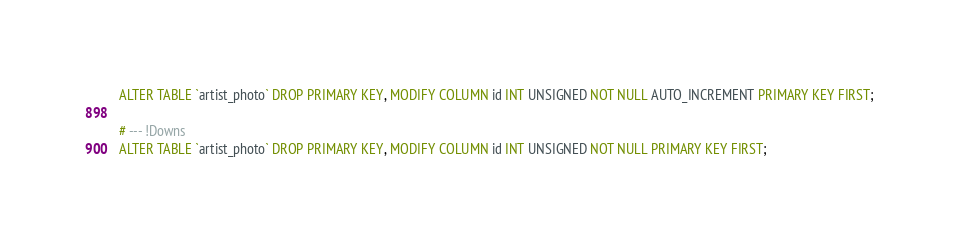<code> <loc_0><loc_0><loc_500><loc_500><_SQL_>ALTER TABLE `artist_photo` DROP PRIMARY KEY, MODIFY COLUMN id INT UNSIGNED NOT NULL AUTO_INCREMENT PRIMARY KEY FIRST;

# --- !Downs
ALTER TABLE `artist_photo` DROP PRIMARY KEY, MODIFY COLUMN id INT UNSIGNED NOT NULL PRIMARY KEY FIRST;

</code> 